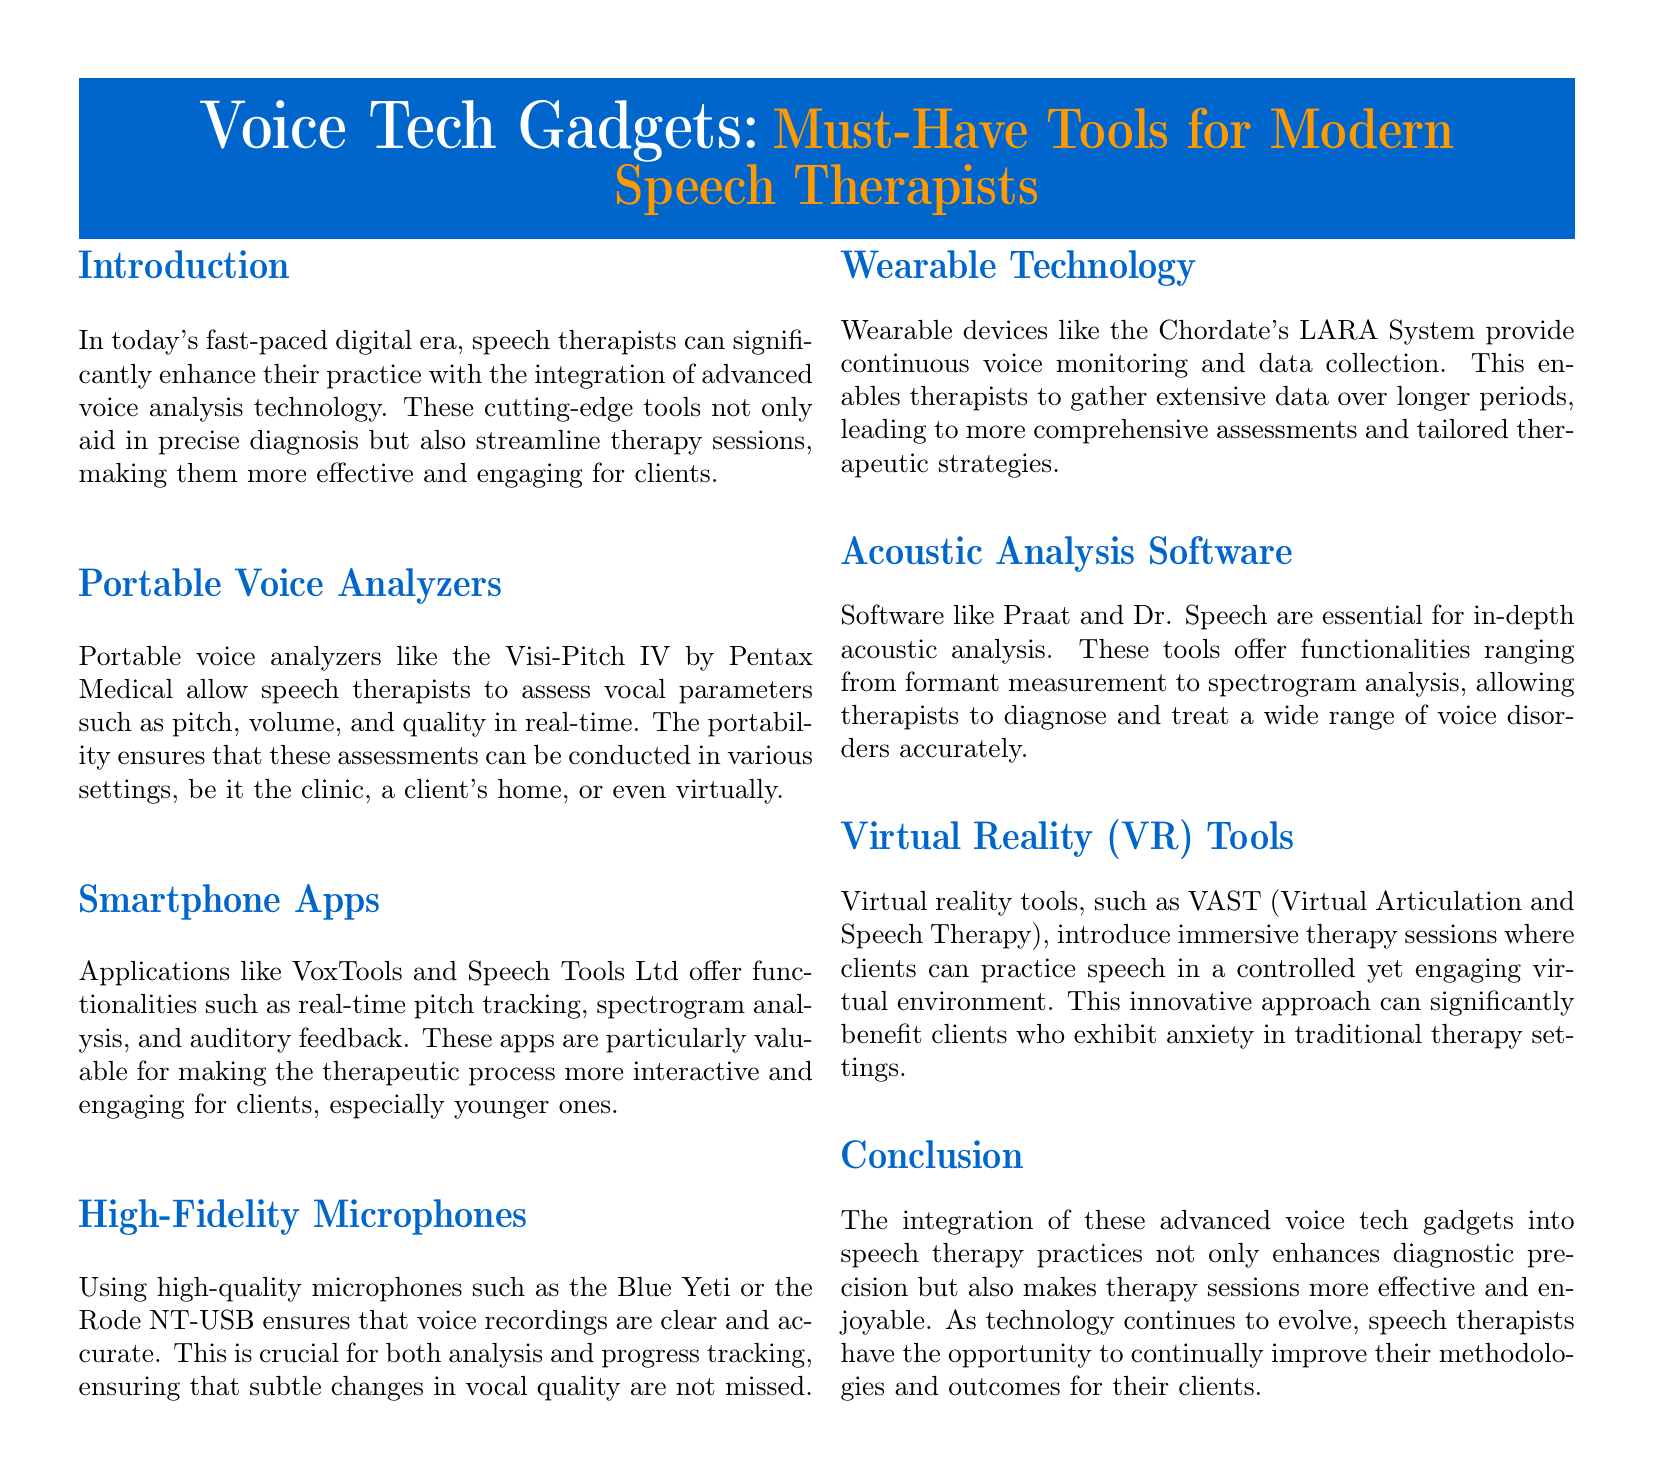What are portable voice analyzers used for? Portable voice analyzers are used to assess vocal parameters such as pitch, volume, and quality in real-time.
Answer: Assess vocal parameters Which smartphone app is mentioned in the document? The document mentions VoxTools as one of the smartphone apps available for speech therapists.
Answer: VoxTools What is the benefit of using high-fidelity microphones? High-fidelity microphones ensure that voice recordings are clear and accurate, crucial for analysis and progress tracking.
Answer: Clear and accurate recordings What kind of therapy does the VAST tool provide? VAST provides immersive therapy sessions in a controlled yet engaging virtual environment.
Answer: Immersive therapy sessions What does the LARA System monitor? The LARA System provides continuous voice monitoring and data collection.
Answer: Continuous voice monitoring How many sections are there in the document? The document has seven sections including the introduction and conclusion.
Answer: Seven sections 